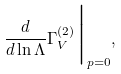Convert formula to latex. <formula><loc_0><loc_0><loc_500><loc_500>\frac { d } { d \ln \Lambda } \Gamma ^ { ( 2 ) } _ { V } \Big | _ { p = 0 } ,</formula> 